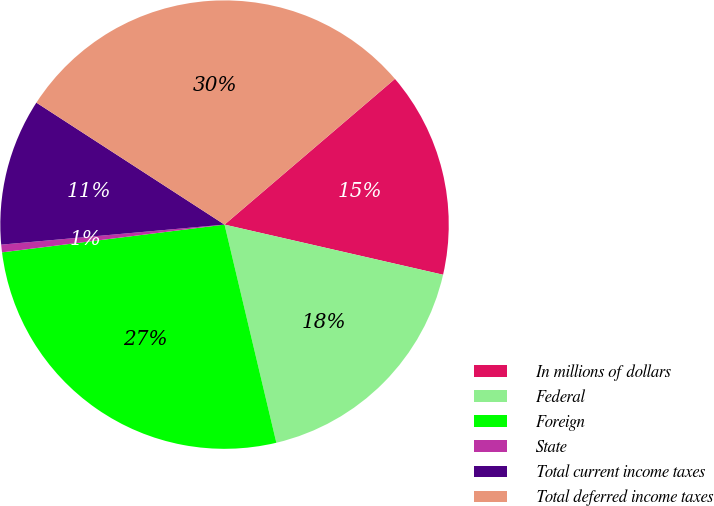<chart> <loc_0><loc_0><loc_500><loc_500><pie_chart><fcel>In millions of dollars<fcel>Federal<fcel>Foreign<fcel>State<fcel>Total current income taxes<fcel>Total deferred income taxes<nl><fcel>14.85%<fcel>17.7%<fcel>26.74%<fcel>0.55%<fcel>10.58%<fcel>29.59%<nl></chart> 